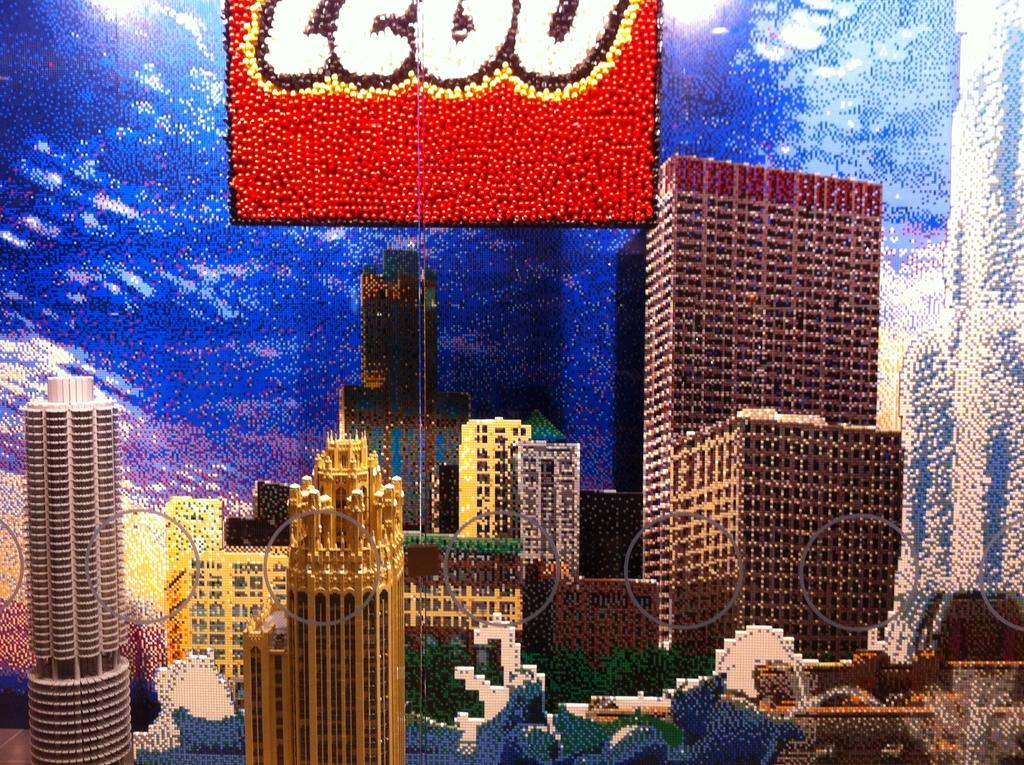What type of image is being described? The image is a graphic. What structures can be seen in the graphic? There are buildings in the image. What type of natural elements are present in the graphic? There are trees in the image. What additional information is provided at the top of the graphic? There is text written at the top of the image. Can you tell me how many horses are depicted in the graphic? There are no horses present in the graphic; it features buildings, trees, and text. Is there a faucet visible in the graphic? There is no faucet present in the graphic; it only contains buildings, trees, and text. 